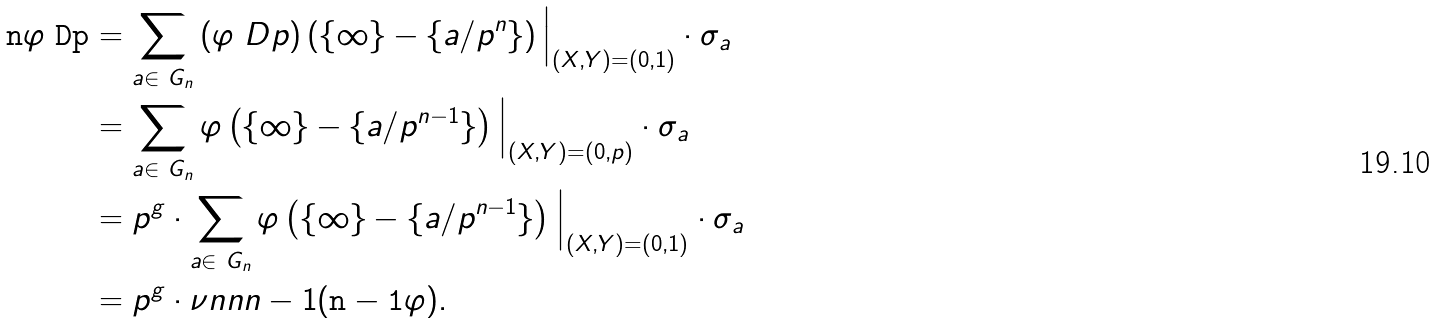Convert formula to latex. <formula><loc_0><loc_0><loc_500><loc_500>\tt { n } { \varphi \ D p } & = \sum _ { a \in \ G _ { n } } \left ( \varphi \ D p \right ) \left ( \{ \infty \} - \{ a / p ^ { n } \} \right ) \Big | _ { ( X , Y ) = ( 0 , 1 ) } \cdot \sigma _ { a } \\ & = \sum _ { a \in \ G _ { n } } \varphi \left ( \{ \infty \} - \{ a / p ^ { n - 1 } \} \right ) \Big | _ { ( X , Y ) = ( 0 , p ) } \cdot \sigma _ { a } \\ & = p ^ { g } \cdot \sum _ { a \in \ G _ { n } } \varphi \left ( \{ \infty \} - \{ a / p ^ { n - 1 } \} \right ) \Big | _ { ( X , Y ) = ( 0 , 1 ) } \cdot \sigma _ { a } \\ & = p ^ { g } \cdot \nu n { n } { n - 1 } ( \tt { n - 1 } { \varphi } ) .</formula> 